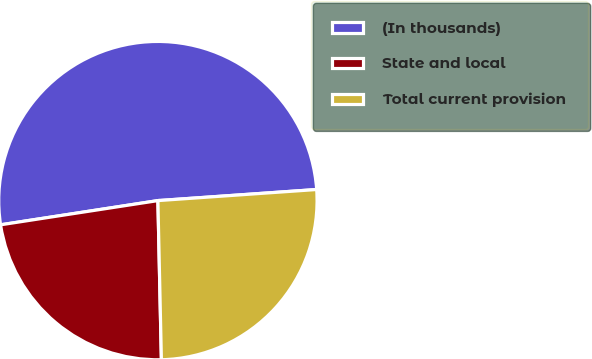<chart> <loc_0><loc_0><loc_500><loc_500><pie_chart><fcel>(In thousands)<fcel>State and local<fcel>Total current provision<nl><fcel>51.32%<fcel>22.92%<fcel>25.76%<nl></chart> 